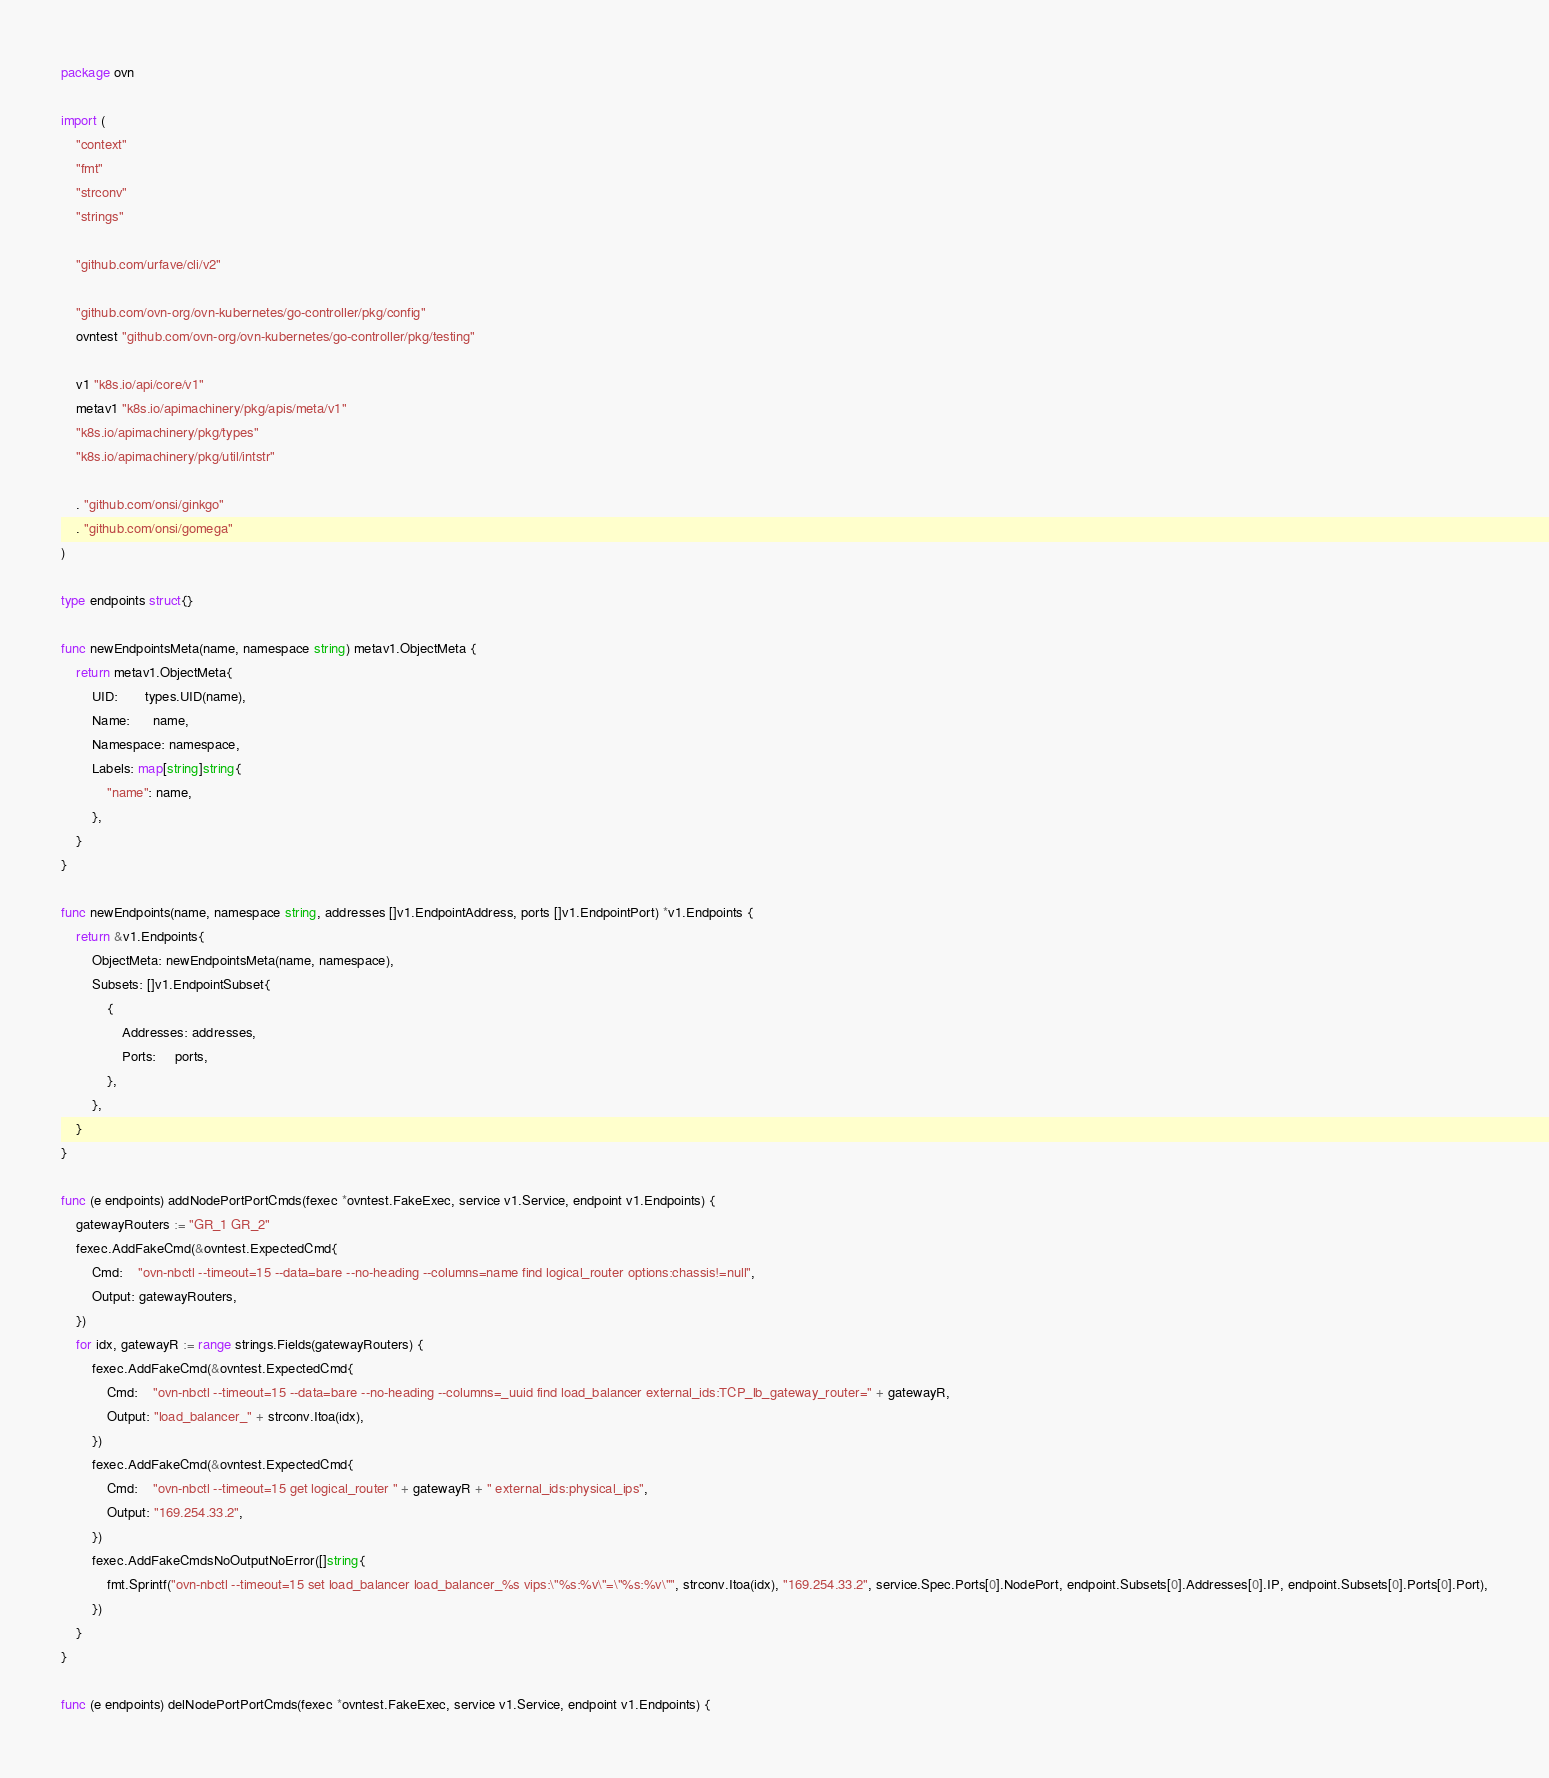<code> <loc_0><loc_0><loc_500><loc_500><_Go_>package ovn

import (
	"context"
	"fmt"
	"strconv"
	"strings"

	"github.com/urfave/cli/v2"

	"github.com/ovn-org/ovn-kubernetes/go-controller/pkg/config"
	ovntest "github.com/ovn-org/ovn-kubernetes/go-controller/pkg/testing"

	v1 "k8s.io/api/core/v1"
	metav1 "k8s.io/apimachinery/pkg/apis/meta/v1"
	"k8s.io/apimachinery/pkg/types"
	"k8s.io/apimachinery/pkg/util/intstr"

	. "github.com/onsi/ginkgo"
	. "github.com/onsi/gomega"
)

type endpoints struct{}

func newEndpointsMeta(name, namespace string) metav1.ObjectMeta {
	return metav1.ObjectMeta{
		UID:       types.UID(name),
		Name:      name,
		Namespace: namespace,
		Labels: map[string]string{
			"name": name,
		},
	}
}

func newEndpoints(name, namespace string, addresses []v1.EndpointAddress, ports []v1.EndpointPort) *v1.Endpoints {
	return &v1.Endpoints{
		ObjectMeta: newEndpointsMeta(name, namespace),
		Subsets: []v1.EndpointSubset{
			{
				Addresses: addresses,
				Ports:     ports,
			},
		},
	}
}

func (e endpoints) addNodePortPortCmds(fexec *ovntest.FakeExec, service v1.Service, endpoint v1.Endpoints) {
	gatewayRouters := "GR_1 GR_2"
	fexec.AddFakeCmd(&ovntest.ExpectedCmd{
		Cmd:    "ovn-nbctl --timeout=15 --data=bare --no-heading --columns=name find logical_router options:chassis!=null",
		Output: gatewayRouters,
	})
	for idx, gatewayR := range strings.Fields(gatewayRouters) {
		fexec.AddFakeCmd(&ovntest.ExpectedCmd{
			Cmd:    "ovn-nbctl --timeout=15 --data=bare --no-heading --columns=_uuid find load_balancer external_ids:TCP_lb_gateway_router=" + gatewayR,
			Output: "load_balancer_" + strconv.Itoa(idx),
		})
		fexec.AddFakeCmd(&ovntest.ExpectedCmd{
			Cmd:    "ovn-nbctl --timeout=15 get logical_router " + gatewayR + " external_ids:physical_ips",
			Output: "169.254.33.2",
		})
		fexec.AddFakeCmdsNoOutputNoError([]string{
			fmt.Sprintf("ovn-nbctl --timeout=15 set load_balancer load_balancer_%s vips:\"%s:%v\"=\"%s:%v\"", strconv.Itoa(idx), "169.254.33.2", service.Spec.Ports[0].NodePort, endpoint.Subsets[0].Addresses[0].IP, endpoint.Subsets[0].Ports[0].Port),
		})
	}
}

func (e endpoints) delNodePortPortCmds(fexec *ovntest.FakeExec, service v1.Service, endpoint v1.Endpoints) {</code> 